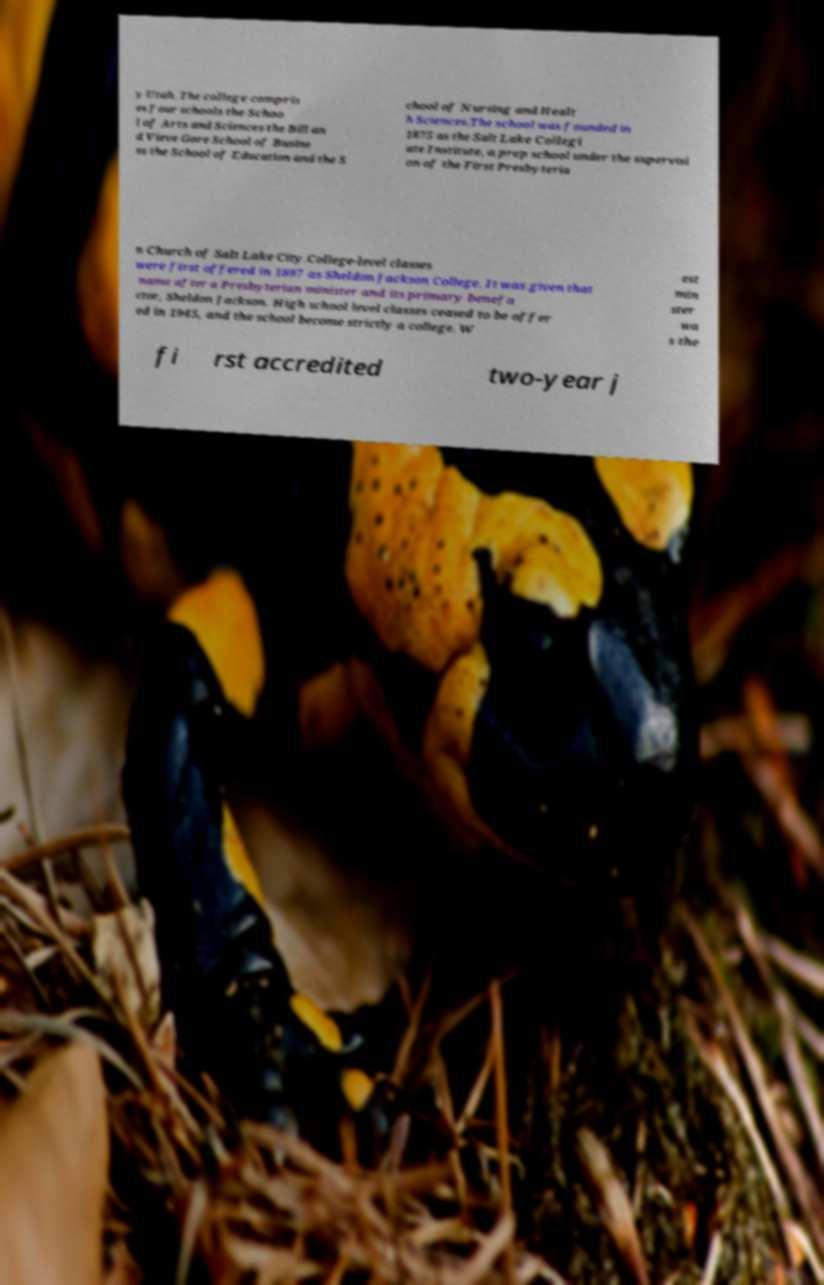Could you extract and type out the text from this image? y Utah. The college compris es four schools the Schoo l of Arts and Sciences the Bill an d Vieve Gore School of Busine ss the School of Education and the S chool of Nursing and Healt h Sciences.The school was founded in 1875 as the Salt Lake Collegi ate Institute, a prep school under the supervisi on of the First Presbyteria n Church of Salt Lake City.College-level classes were first offered in 1897 as Sheldon Jackson College. It was given that name after a Presbyterian minister and its primary benefa ctor, Sheldon Jackson. High school level classes ceased to be offer ed in 1945, and the school become strictly a college. W est min ster wa s the fi rst accredited two-year j 